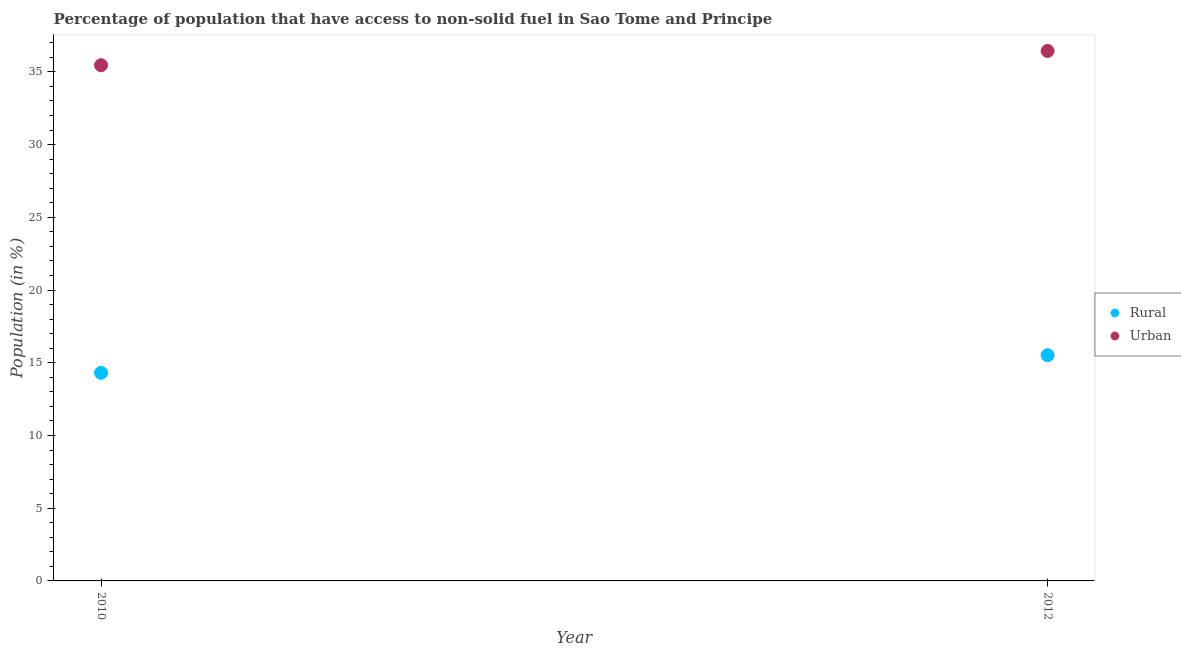What is the urban population in 2010?
Provide a succinct answer. 35.46. Across all years, what is the maximum urban population?
Make the answer very short. 36.44. Across all years, what is the minimum urban population?
Give a very brief answer. 35.46. In which year was the rural population minimum?
Provide a short and direct response. 2010. What is the total urban population in the graph?
Make the answer very short. 71.9. What is the difference between the rural population in 2010 and that in 2012?
Make the answer very short. -1.21. What is the difference between the rural population in 2010 and the urban population in 2012?
Make the answer very short. -22.13. What is the average rural population per year?
Your response must be concise. 14.91. In the year 2012, what is the difference between the rural population and urban population?
Provide a short and direct response. -20.92. In how many years, is the rural population greater than 21 %?
Ensure brevity in your answer.  0. What is the ratio of the urban population in 2010 to that in 2012?
Offer a terse response. 0.97. Is the urban population in 2010 less than that in 2012?
Provide a succinct answer. Yes. In how many years, is the rural population greater than the average rural population taken over all years?
Ensure brevity in your answer.  1. Does the urban population monotonically increase over the years?
Give a very brief answer. Yes. Is the rural population strictly greater than the urban population over the years?
Provide a succinct answer. No. How many years are there in the graph?
Your answer should be very brief. 2. Does the graph contain grids?
Make the answer very short. No. Where does the legend appear in the graph?
Ensure brevity in your answer.  Center right. How are the legend labels stacked?
Provide a succinct answer. Vertical. What is the title of the graph?
Offer a very short reply. Percentage of population that have access to non-solid fuel in Sao Tome and Principe. What is the label or title of the Y-axis?
Keep it short and to the point. Population (in %). What is the Population (in %) in Rural in 2010?
Make the answer very short. 14.31. What is the Population (in %) of Urban in 2010?
Ensure brevity in your answer.  35.46. What is the Population (in %) in Rural in 2012?
Your answer should be compact. 15.52. What is the Population (in %) in Urban in 2012?
Keep it short and to the point. 36.44. Across all years, what is the maximum Population (in %) in Rural?
Keep it short and to the point. 15.52. Across all years, what is the maximum Population (in %) of Urban?
Give a very brief answer. 36.44. Across all years, what is the minimum Population (in %) in Rural?
Make the answer very short. 14.31. Across all years, what is the minimum Population (in %) in Urban?
Provide a succinct answer. 35.46. What is the total Population (in %) of Rural in the graph?
Your answer should be very brief. 29.83. What is the total Population (in %) in Urban in the graph?
Offer a very short reply. 71.9. What is the difference between the Population (in %) of Rural in 2010 and that in 2012?
Keep it short and to the point. -1.21. What is the difference between the Population (in %) in Urban in 2010 and that in 2012?
Offer a very short reply. -0.98. What is the difference between the Population (in %) of Rural in 2010 and the Population (in %) of Urban in 2012?
Your response must be concise. -22.13. What is the average Population (in %) in Rural per year?
Keep it short and to the point. 14.91. What is the average Population (in %) in Urban per year?
Your answer should be compact. 35.95. In the year 2010, what is the difference between the Population (in %) in Rural and Population (in %) in Urban?
Make the answer very short. -21.15. In the year 2012, what is the difference between the Population (in %) of Rural and Population (in %) of Urban?
Give a very brief answer. -20.92. What is the ratio of the Population (in %) in Rural in 2010 to that in 2012?
Offer a very short reply. 0.92. What is the ratio of the Population (in %) of Urban in 2010 to that in 2012?
Your answer should be compact. 0.97. What is the difference between the highest and the second highest Population (in %) in Rural?
Offer a very short reply. 1.21. What is the difference between the highest and the second highest Population (in %) in Urban?
Ensure brevity in your answer.  0.98. What is the difference between the highest and the lowest Population (in %) in Rural?
Provide a short and direct response. 1.21. What is the difference between the highest and the lowest Population (in %) of Urban?
Give a very brief answer. 0.98. 